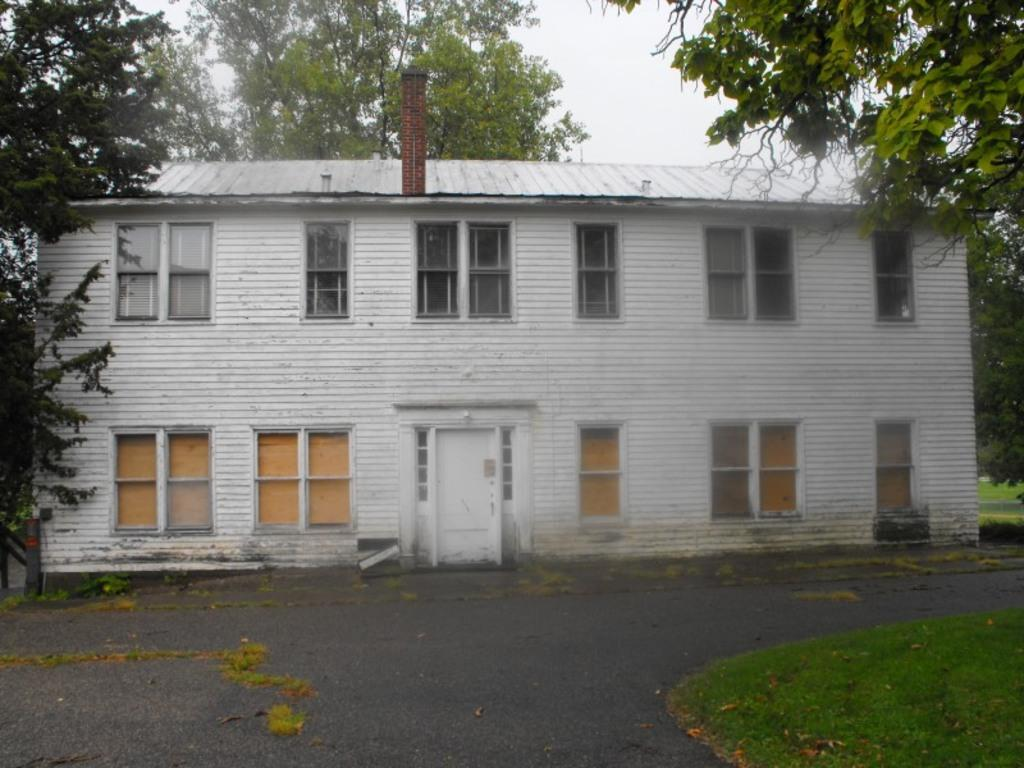What is the main structure in the picture? There is a building in the picture. What feature of the building is mentioned in the facts? The building has many windows. What can be seen in the vicinity of the building? There are trees around the building. What is located in front of the building? There is a road in front of the building. What type of ticket can be seen in the picture? There is no ticket present in the picture; it features a building with many windows, trees, and a road in front of it. What answer is provided by the building in the picture? Buildings do not provide answers; they are inanimate structures. 